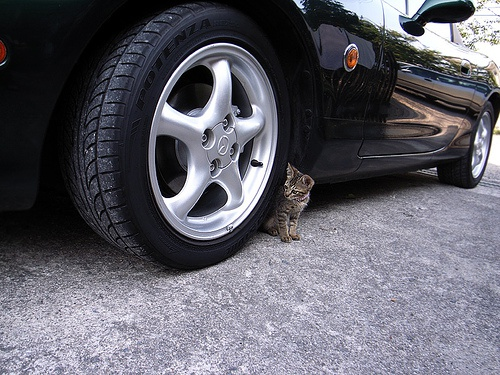Describe the objects in this image and their specific colors. I can see car in black, gray, white, and darkgray tones and cat in black, gray, and darkgray tones in this image. 